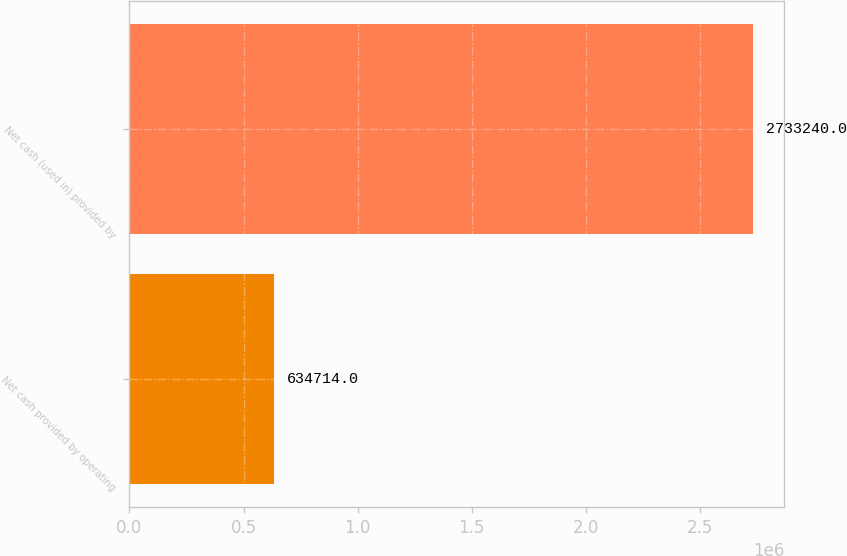Convert chart to OTSL. <chart><loc_0><loc_0><loc_500><loc_500><bar_chart><fcel>Net cash provided by operating<fcel>Net cash (used in) provided by<nl><fcel>634714<fcel>2.73324e+06<nl></chart> 